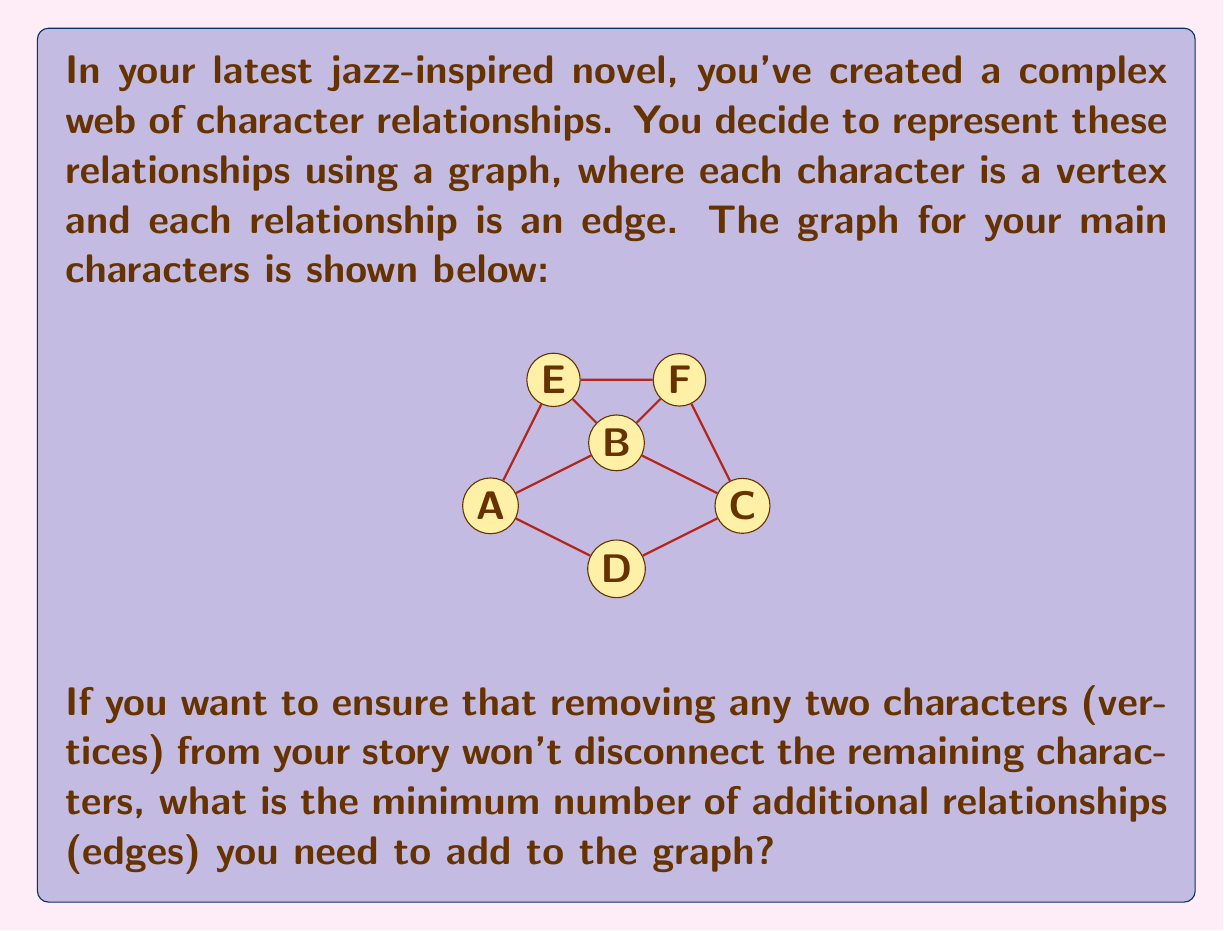Provide a solution to this math problem. To solve this problem, we need to understand the concept of 3-vertex-connectivity in graph theory. A graph is 3-vertex-connected if it remains connected after the removal of any two vertices.

Let's approach this step-by-step:

1) First, we need to check if the current graph is already 3-vertex-connected. We can do this by trying to find a pair of vertices that, when removed, disconnect the graph.

2) By inspection, we can see that removing vertices B and C disconnects the graph into three components: {A}, {D}, and {E,F}. This means the graph is not 3-vertex-connected.

3) To make the graph 3-vertex-connected, we need to add edges such that no pair of vertex removals can disconnect the graph.

4) One way to achieve this is to ensure that each vertex has a degree of at least 3. Currently, vertices A and D have a degree of 2.

5) The minimum number of edges to add would be those that increase the degrees of A and D to 3. This can be done by adding one edge to each:
   - We can add edge A-F
   - We can add edge D-E or D-F (let's choose D-E)

6) After adding these two edges, every vertex will have a degree of at least 3, and the graph will be 3-vertex-connected.

7) We can verify that no pair of vertex removals can now disconnect the graph.

Therefore, the minimum number of additional edges required is 2.
Answer: 2 